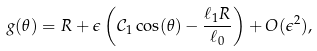<formula> <loc_0><loc_0><loc_500><loc_500>g ( \theta ) = R + \epsilon \left ( \mathcal { C } _ { 1 } \cos ( \theta ) - \frac { \ell _ { 1 } R } { \ell _ { 0 } } \right ) + O ( \epsilon ^ { 2 } ) ,</formula> 